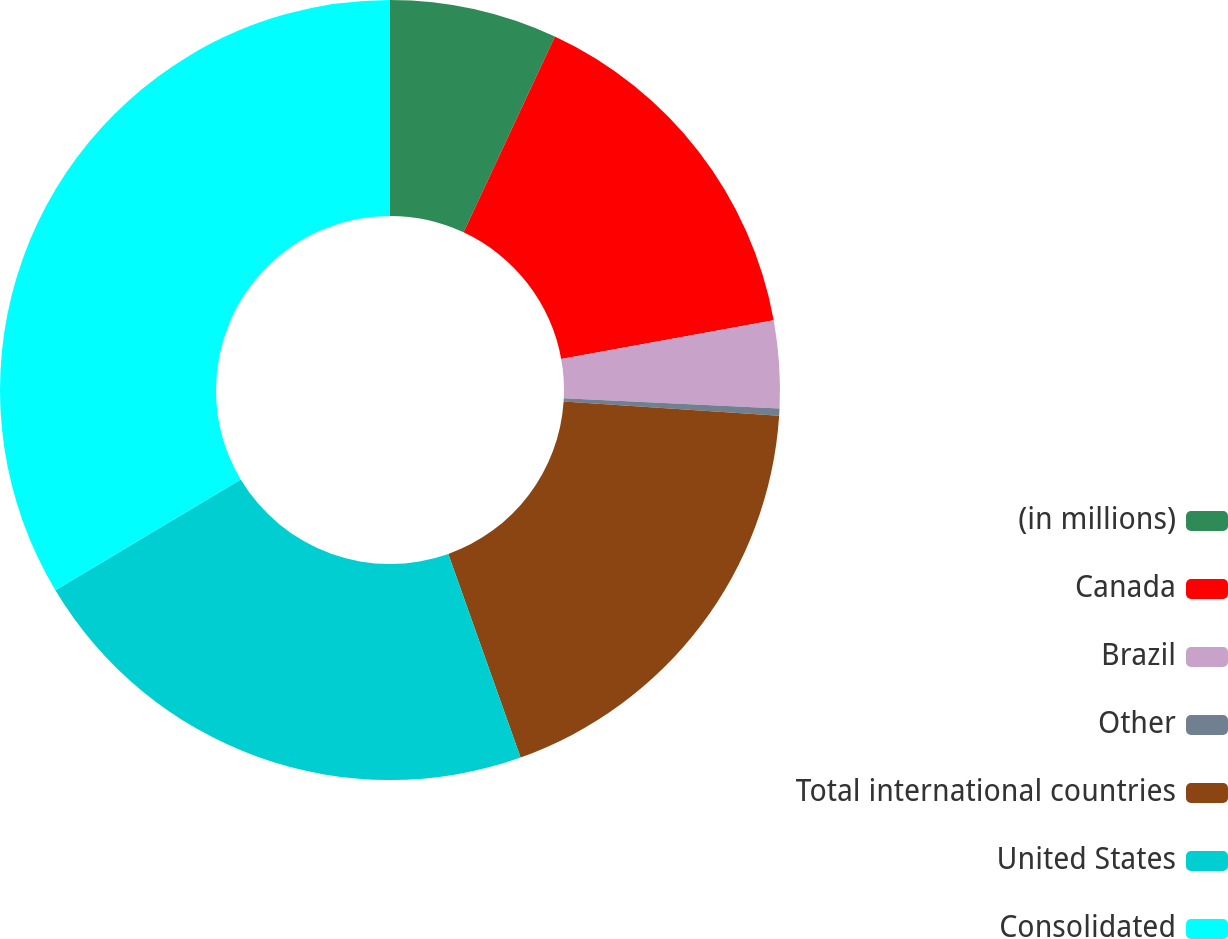Convert chart. <chart><loc_0><loc_0><loc_500><loc_500><pie_chart><fcel>(in millions)<fcel>Canada<fcel>Brazil<fcel>Other<fcel>Total international countries<fcel>United States<fcel>Consolidated<nl><fcel>6.95%<fcel>15.19%<fcel>3.62%<fcel>0.29%<fcel>18.52%<fcel>21.85%<fcel>33.59%<nl></chart> 